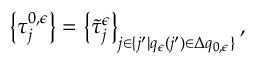<formula> <loc_0><loc_0><loc_500><loc_500>\left \{ \tau _ { j } ^ { 0 , \epsilon } \right \} = \left \{ \tilde { \tau } _ { j } ^ { \epsilon } \right \} _ { j \in \{ j ^ { \prime } | q _ { \epsilon } ( j ^ { \prime } ) \in \Delta q _ { 0 , \epsilon } \} } ,</formula> 